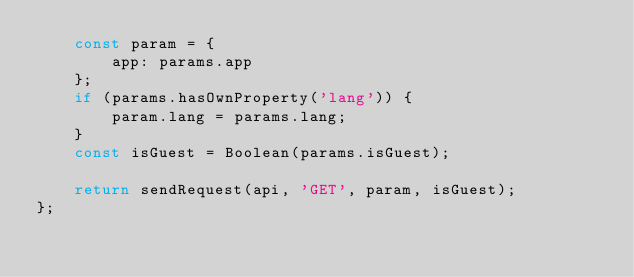Convert code to text. <code><loc_0><loc_0><loc_500><loc_500><_JavaScript_>    const param = {
        app: params.app
    };
    if (params.hasOwnProperty('lang')) {
        param.lang = params.lang;
    }
    const isGuest = Boolean(params.isGuest);

    return sendRequest(api, 'GET', param, isGuest);
};
</code> 